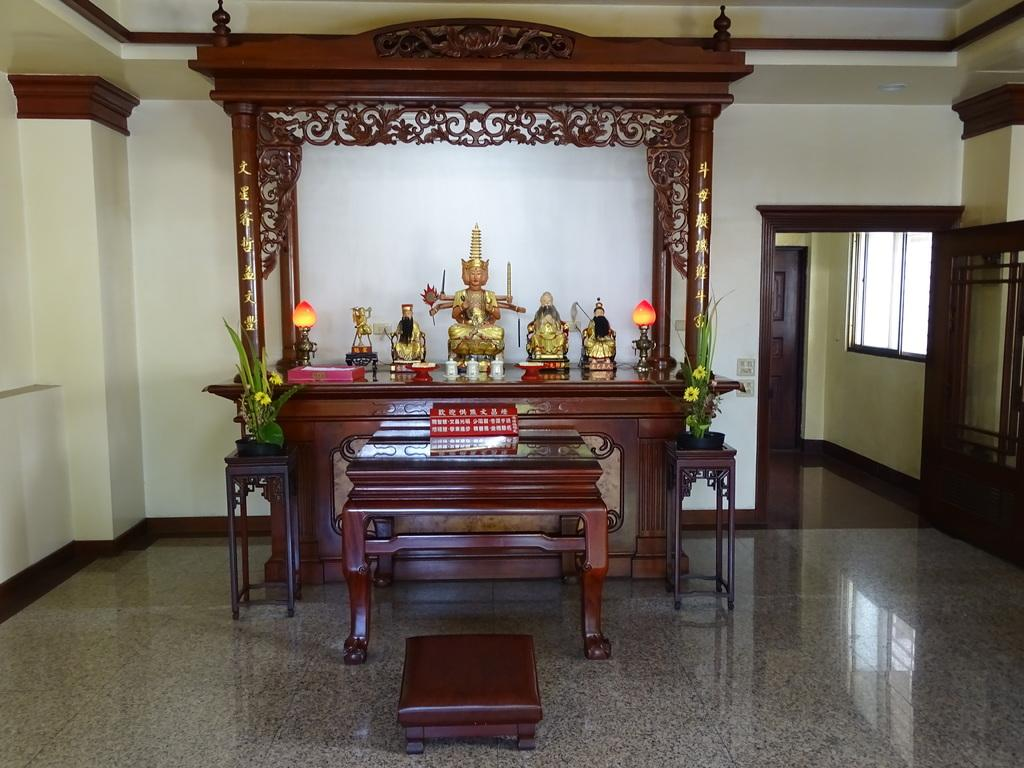What type of space is depicted in the image? The image shows an inner view of a room. What kind of decorative elements can be seen in the room? There are house plants and statues in the room. What furniture is present in the room? There is a side table in the room. How is the room enclosed? The room has walls and doors. What type of crown is placed on the mouth of the statue in the image? There is no statue with a crown on its mouth present in the image. 